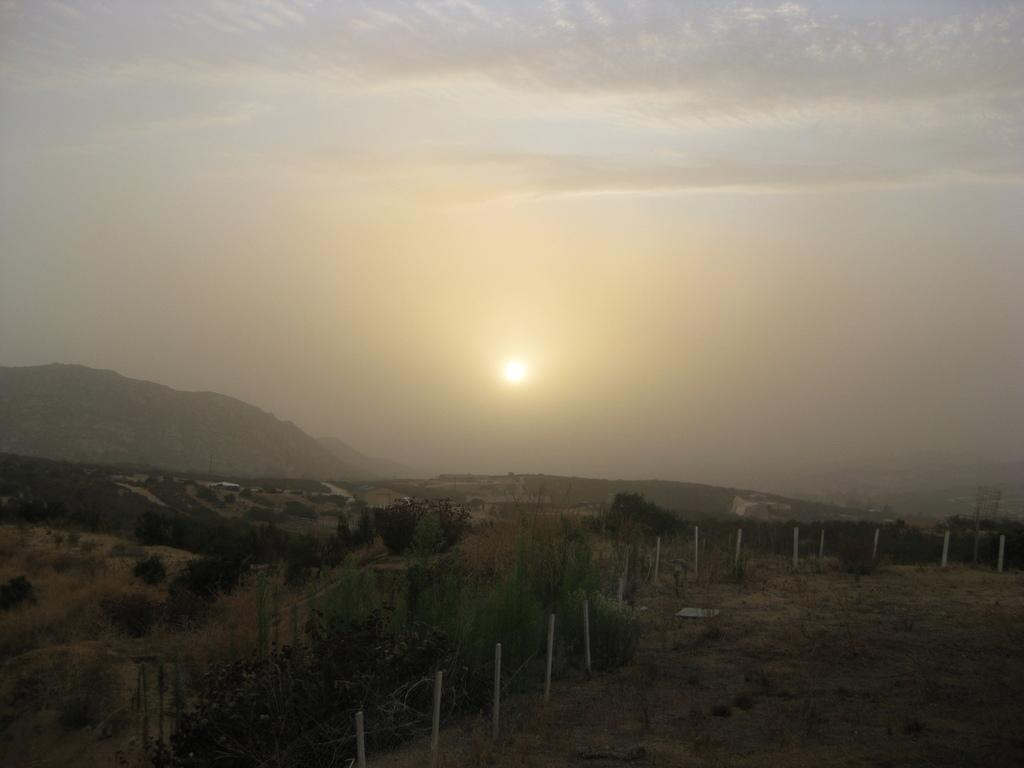What type of vegetation can be seen in the image? There is grass and trees in the image. What are the white color poles in the image used for? The purpose of the white color poles is not specified in the image. What is visible in the background of the image? There is a hill and sky visible in the background of the image. What can be seen in the sky? There are clouds and the sun visible in the sky. What animal is present in the image? There is a dog in the image. What type of sign can be seen on the hill in the image? There is no sign present on the hill in the image. How does the sponge help the dog in the image? There is no sponge present in the image, and therefore it cannot help the dog. 